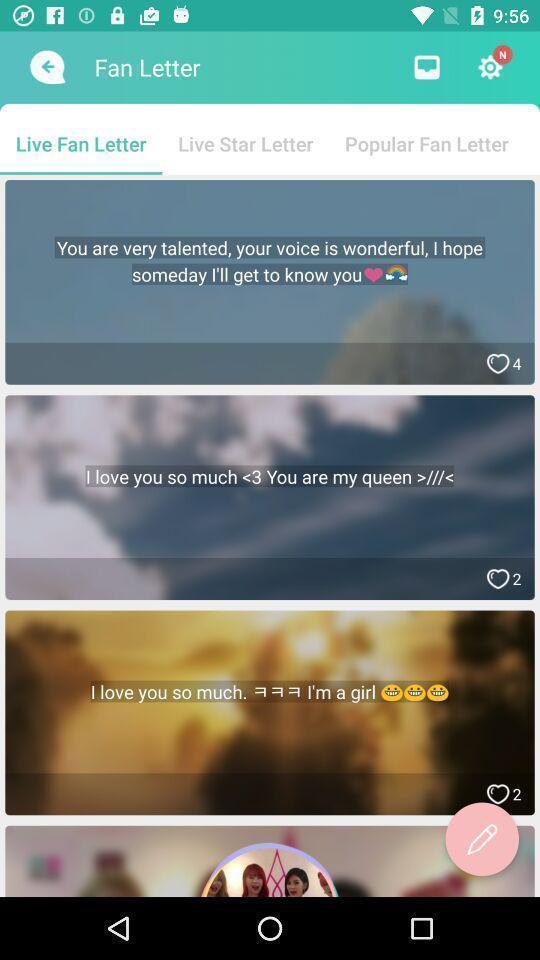Provide a detailed account of this screenshot. Screen displaying the list of sentences. 